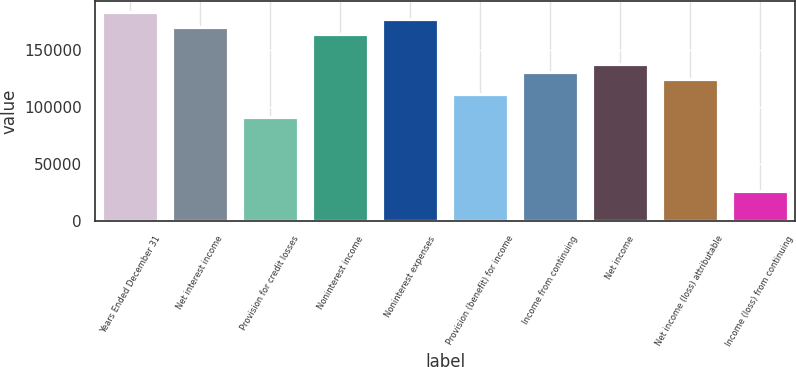<chart> <loc_0><loc_0><loc_500><loc_500><bar_chart><fcel>Years Ended December 31<fcel>Net interest income<fcel>Provision for credit losses<fcel>Noninterest income<fcel>Noninterest expenses<fcel>Provision (benefit) for income<fcel>Income from continuing<fcel>Net income<fcel>Net income (loss) attributable<fcel>Income (loss) from continuing<nl><fcel>183004<fcel>169933<fcel>91502.4<fcel>163397<fcel>176469<fcel>111110<fcel>130718<fcel>137253<fcel>124182<fcel>26143.8<nl></chart> 